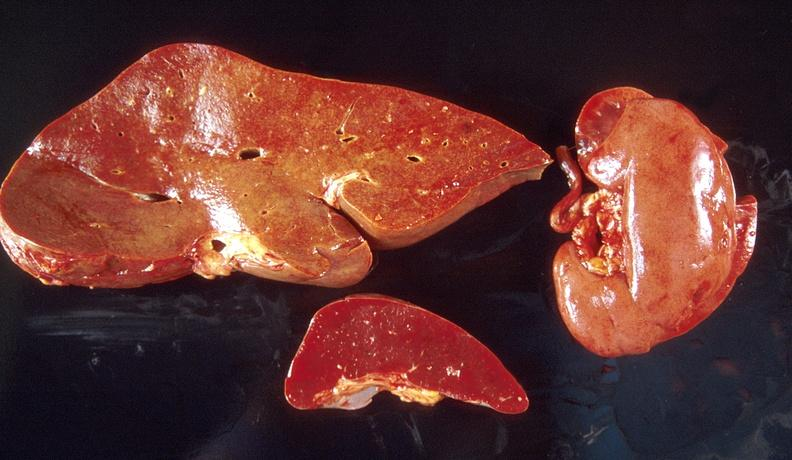s hepatobiliary present?
Answer the question using a single word or phrase. Yes 